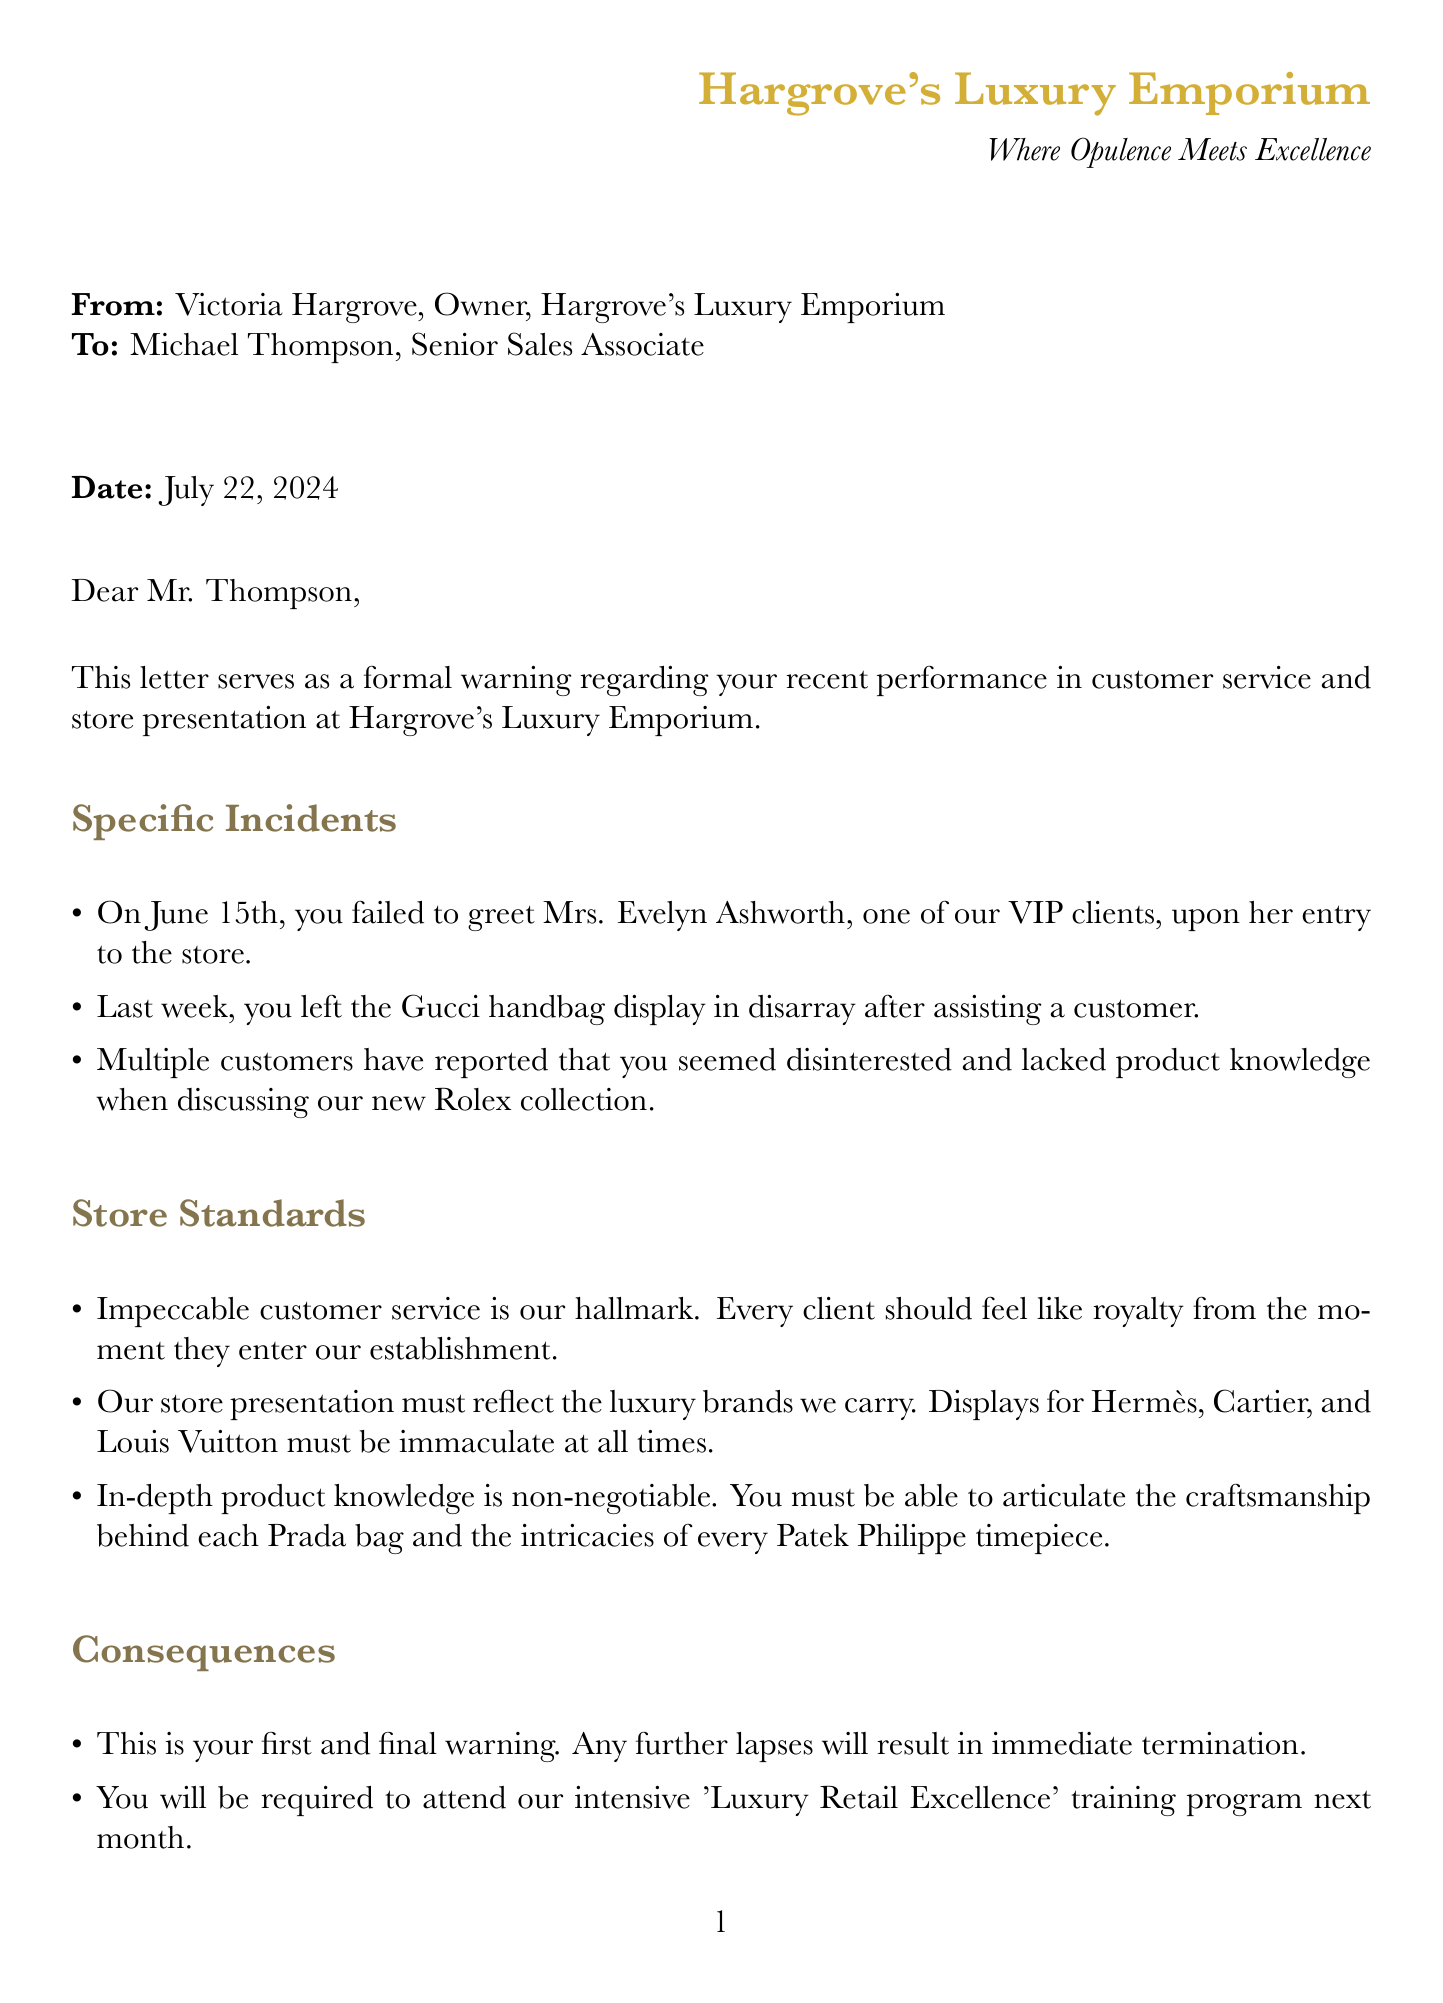What is the sender's name? The sender's name is listed at the beginning of the letter as Victoria Hargrove.
Answer: Victoria Hargrove Who is the recipient of the letter? The recipient is identified as Michael Thompson, the Senior Sales Associate.
Answer: Michael Thompson What specific date is mentioned in the letter? The letter includes the phrase "Date: \today", indicating the letter’s date is the current date.
Answer: Today’s date What incident occurred on June 15th? The letter states that on June 15th, the employee failed to greet a VIP client.
Answer: Failed to greet a VIP client What will happen if there are further lapses in performance? The letter specifies that any further lapses will result in immediate termination.
Answer: Immediate termination What training program must the employee attend? The letter mentions an intensive 'Luxury Retail Excellence' training program the employee must attend next month.
Answer: Luxury Retail Excellence How many hours per week is the employee expected to study product catalogs? The expectations state a minimum of 2 hours per week is required for studying product catalogs and brand histories.
Answer: 2 hours What is the primary expectation for customer greeting? The expectation is to greet every customer within 10 seconds of their entry.
Answer: 10 seconds What is emphasized as the hallmark of the store? The letter states that impeccable customer service is the hallmark of Hargrove's Luxury Emporium.
Answer: Impeccable customer service What is the main message in the closing remarks? The closing remarks emphasize the importance of offering an unparalleled luxury experience and expecting perfection from every team member.
Answer: Unparalleled luxury experience 